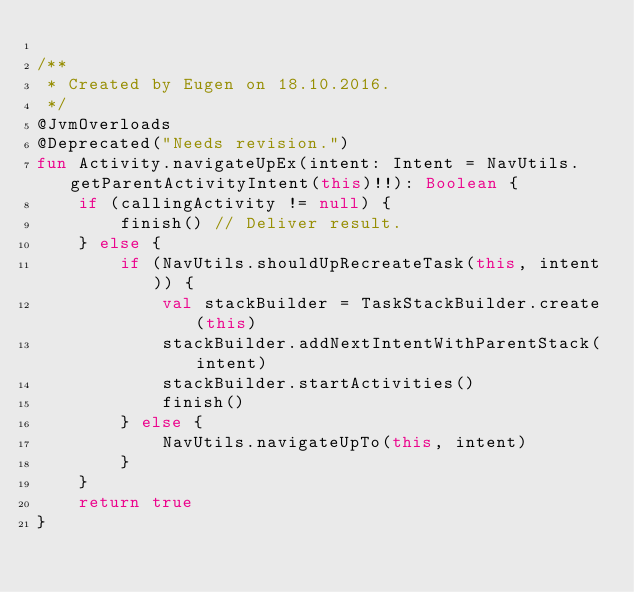<code> <loc_0><loc_0><loc_500><loc_500><_Kotlin_>
/**
 * Created by Eugen on 18.10.2016.
 */
@JvmOverloads
@Deprecated("Needs revision.")
fun Activity.navigateUpEx(intent: Intent = NavUtils.getParentActivityIntent(this)!!): Boolean {
    if (callingActivity != null) {
        finish() // Deliver result.
    } else {
        if (NavUtils.shouldUpRecreateTask(this, intent)) {
            val stackBuilder = TaskStackBuilder.create(this)
            stackBuilder.addNextIntentWithParentStack(intent)
            stackBuilder.startActivities()
            finish()
        } else {
            NavUtils.navigateUpTo(this, intent)
        }
    }
    return true
}
</code> 